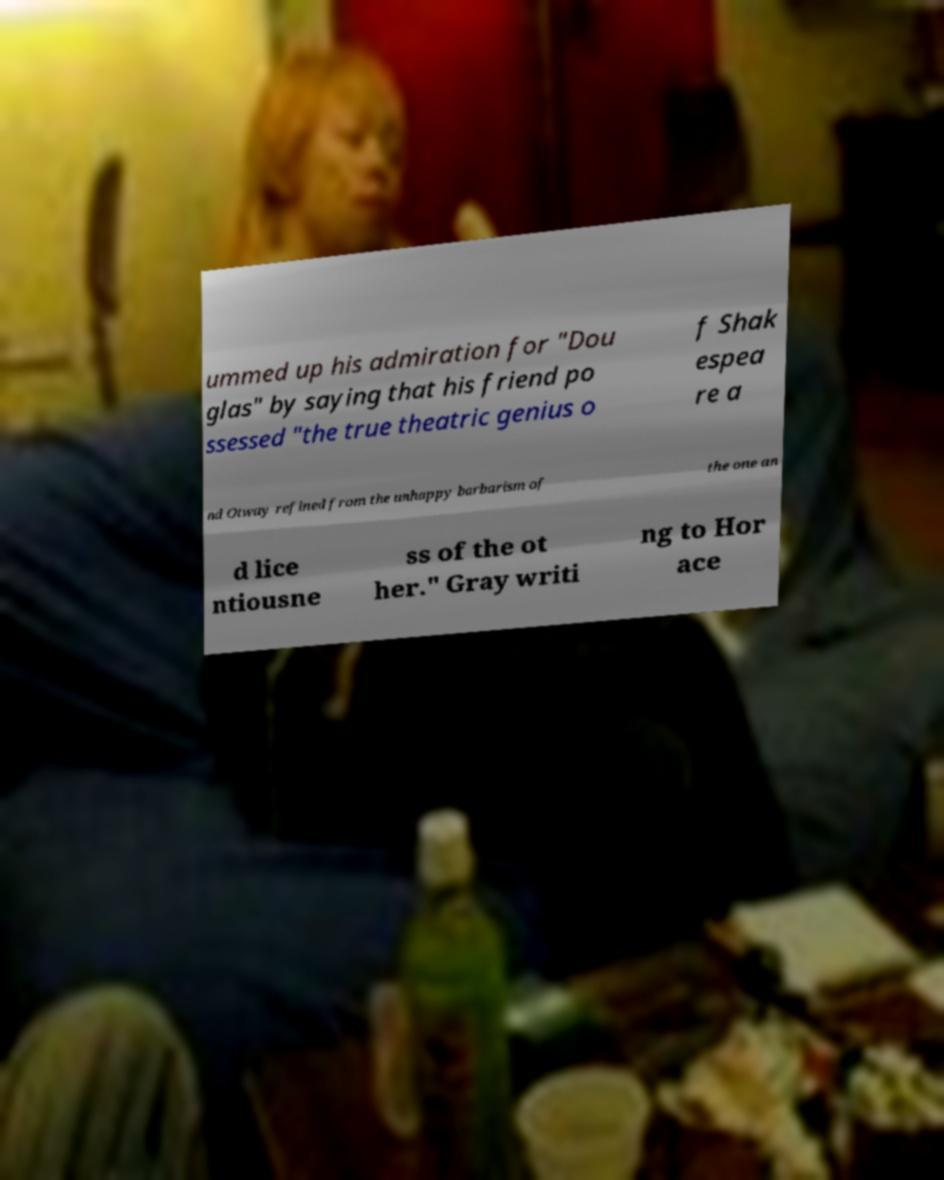Can you read and provide the text displayed in the image?This photo seems to have some interesting text. Can you extract and type it out for me? ummed up his admiration for "Dou glas" by saying that his friend po ssessed "the true theatric genius o f Shak espea re a nd Otway refined from the unhappy barbarism of the one an d lice ntiousne ss of the ot her." Gray writi ng to Hor ace 